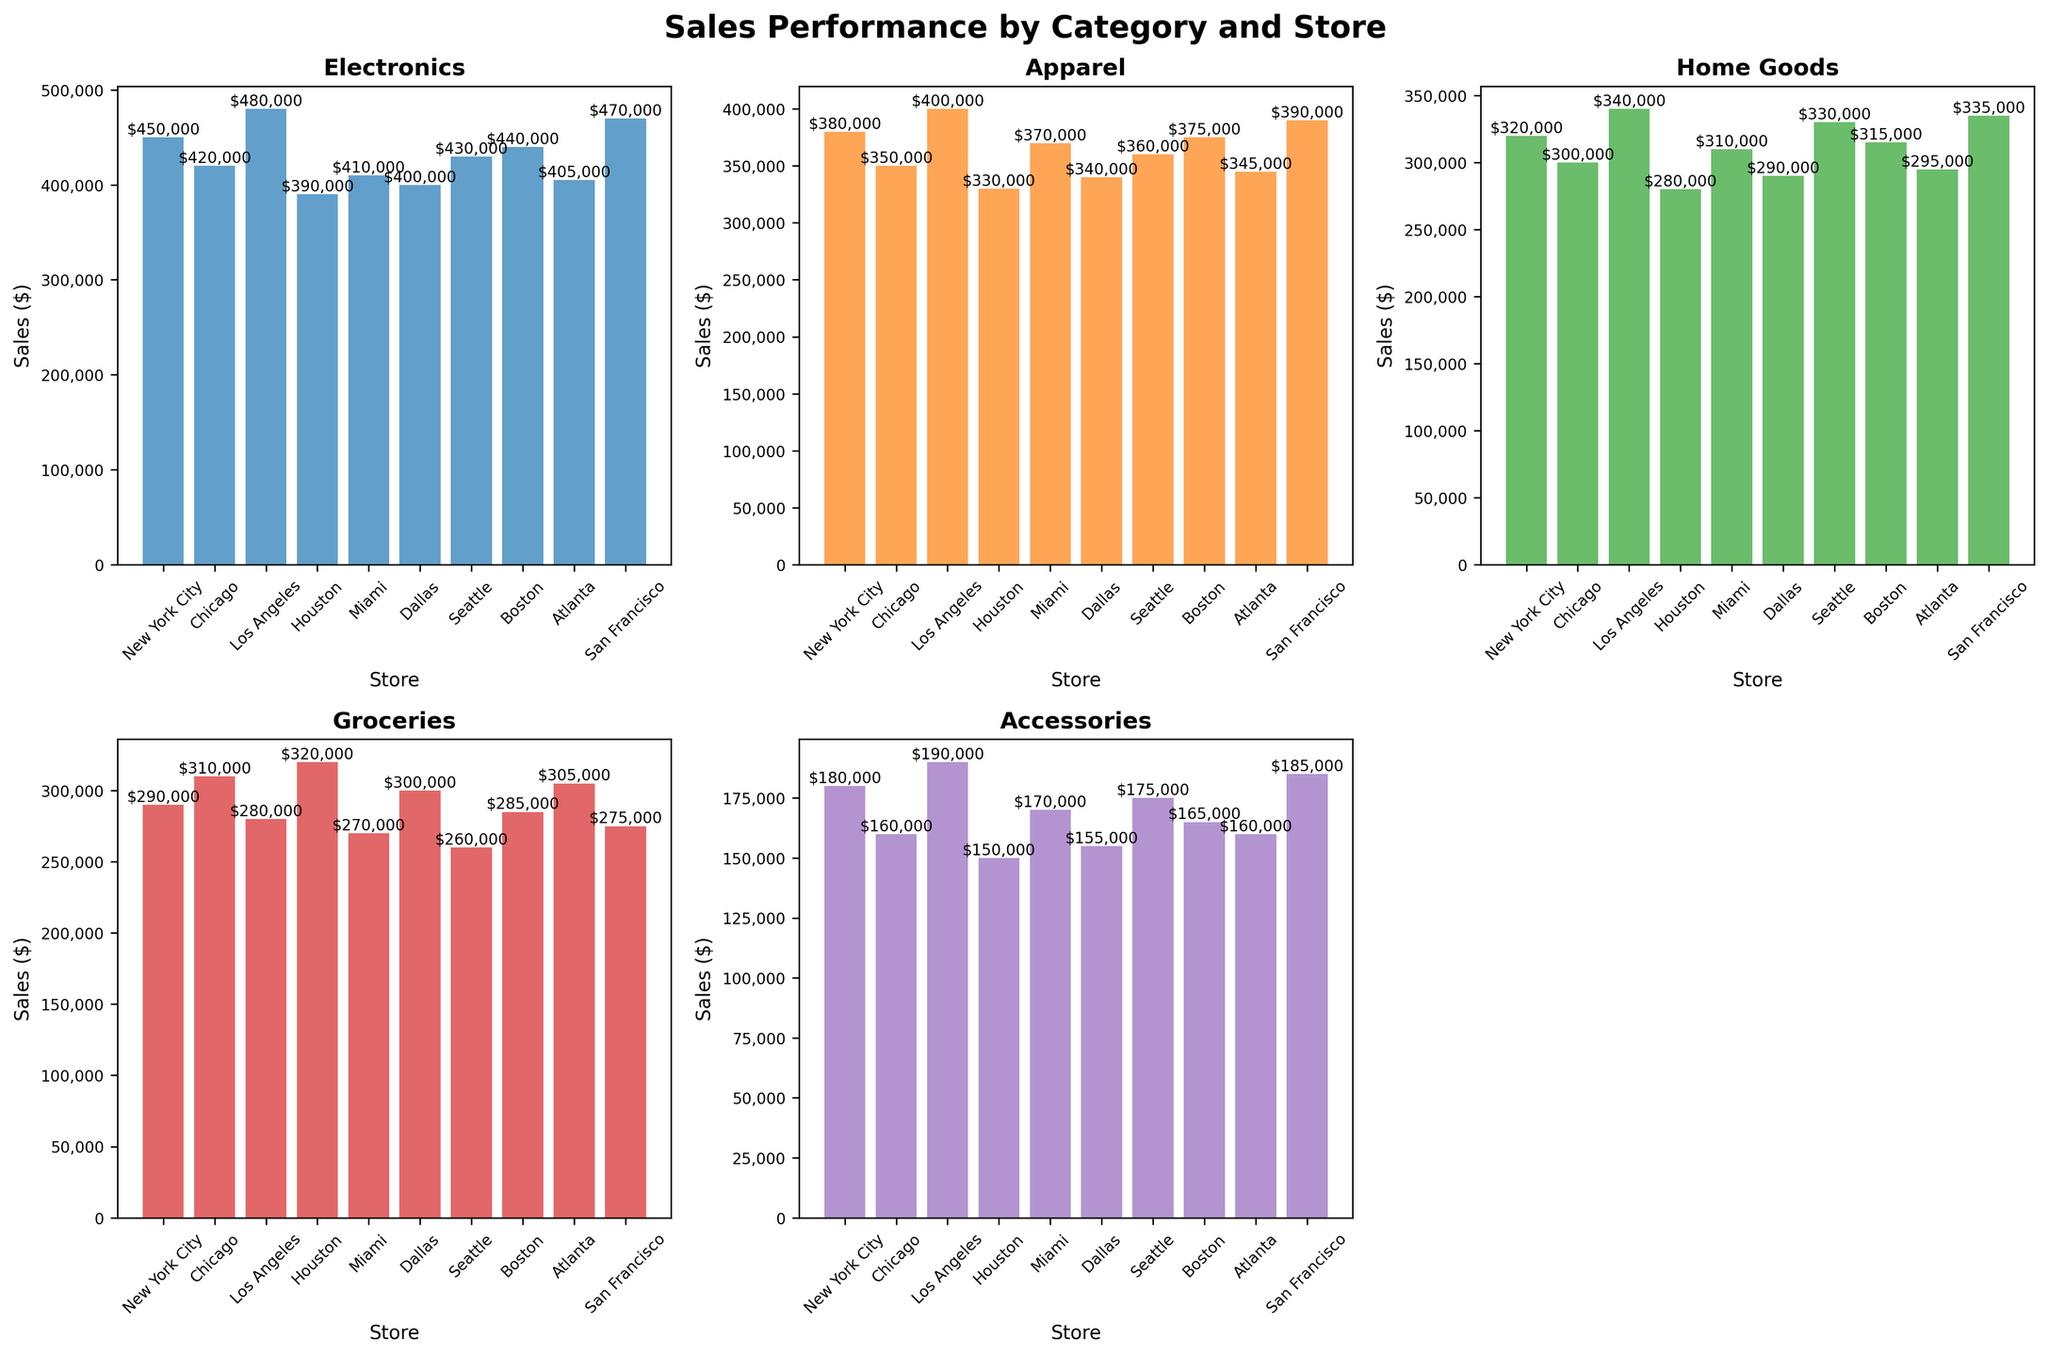What is the title of the entire grid of subplots? The title of the figure is typically displayed at the top center of the grid of subplots. Here, it is labeled as 'Sales Performance by Category and Store'.
Answer: Sales Performance by Category and Store Which store has the highest sales in the Electronics category? To find the highest sales in the Electronics category, look at the corresponding subplot and identify the bar that reaches the highest point. 'Los Angeles' has the highest bar in this category, showing $480,000 in sales.
Answer: Los Angeles How much are the total sales in the Home Goods category across all stores? To find the total sales, sum the values of the Home Goods category for all stores: 320,000 (NYC) + 300,000 (Chicago) + 340,000 (LA) + 280,000 (Houston) + 310,000 (Miami) + 290,000 (Dallas) + 330,000 (Seattle) + 315,000 (Boston) + 295,000 (Atlanta) + 335,000 (SF). The total sales are $3,115,000.
Answer: 3,115,000 Which store has the lowest sales in the Accessories category, and what is the value? Look at the Accessories subplot and identify the lowest bar. The lowest sales value is in 'Houston' with sales of $150,000.
Answer: Houston with $150,000 Compare sales in the Groceries category between New York City and Houston. Which store has higher sales and by how much? Look at the bars for New York City and Houston in the Groceries category. NYC has $290,000, and Houston has $320,000. Houston has higher sales by $30,000.
Answer: Houston by $30,000 What is the average sales value for the Apparel category across all stores? Sum the sales values for the Apparel category and divide by the number of stores: (380,000 + 350,000 + 400,000 + 330,000 + 370,000 + 340,000 + 360,000 + 375,000 + 345,000 + 390,000) / 10. The average is $364,000.
Answer: 364,000 Which category has the highest sales in Dallas? Look at the bars in the subplot for each category at the Dallas location. The highest sale is in the Electronics category, amounting to $400,000.
Answer: Electronics What is the difference in sales of Home Goods between the highest and lowest performing stores? Identify the highest (Los Angeles with $340,000) and lowest (Houston with $280,000) selling stores in the Home Goods category. Subtract the lowest from the highest to get the difference: $340,000 - $280,000 = $60,000.
Answer: 60,000 Which store has more total sales in all categories: Chicago or Miami? Sum the sales figures for all categories for Chicago and Miami. Chicago total: 420,000 + 350,000 + 300,000 + 310,000 + 160,000 = 1,540,000. Miami total: 410,000 + 370,000 + 310,000 + 270,000 + 170,000 = 1,530,000. Chicago has more total sales.
Answer: Chicago 